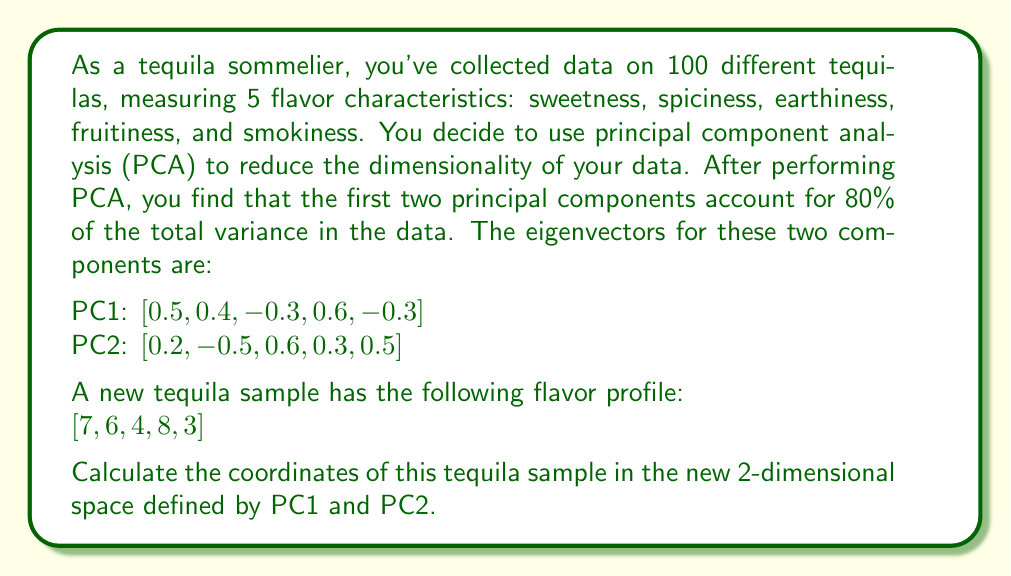Solve this math problem. To solve this problem, we need to project the original data point onto the new space defined by the principal components. This is done by taking the dot product of the data point with each eigenvector.

Let's break it down step by step:

1) The original data point is $[7, 6, 4, 8, 3]$.

2) The eigenvector for PC1 is $[0.5, 0.4, -0.3, 0.6, -0.3]$.

3) The eigenvector for PC2 is $[0.2, -0.5, 0.6, 0.3, 0.5]$.

4) To find the coordinate along PC1, we calculate the dot product of the data point and PC1's eigenvector:

   $$(7 \times 0.5) + (6 \times 0.4) + (4 \times -0.3) + (8 \times 0.6) + (3 \times -0.3)$$
   $$= 3.5 + 2.4 - 1.2 + 4.8 - 0.9 = 8.6$$

5) Similarly, for PC2, we calculate the dot product of the data point and PC2's eigenvector:

   $$(7 \times 0.2) + (6 \times -0.5) + (4 \times 0.6) + (8 \times 0.3) + (3 \times 0.5)$$
   $$= 1.4 - 3 + 2.4 + 2.4 + 1.5 = 4.7$$

Therefore, the coordinates of the tequila sample in the new 2-dimensional space defined by PC1 and PC2 are (8.6, 4.7).
Answer: (8.6, 4.7) 